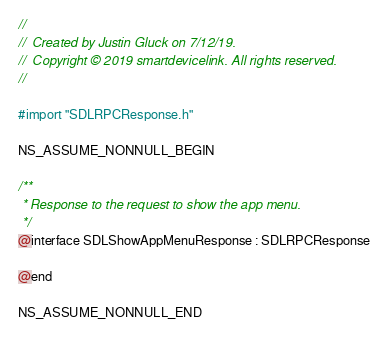Convert code to text. <code><loc_0><loc_0><loc_500><loc_500><_C_>//
//  Created by Justin Gluck on 7/12/19.
//  Copyright © 2019 smartdevicelink. All rights reserved.
//

#import "SDLRPCResponse.h"

NS_ASSUME_NONNULL_BEGIN

/**
 * Response to the request to show the app menu.
 */
@interface SDLShowAppMenuResponse : SDLRPCResponse

@end

NS_ASSUME_NONNULL_END
</code> 